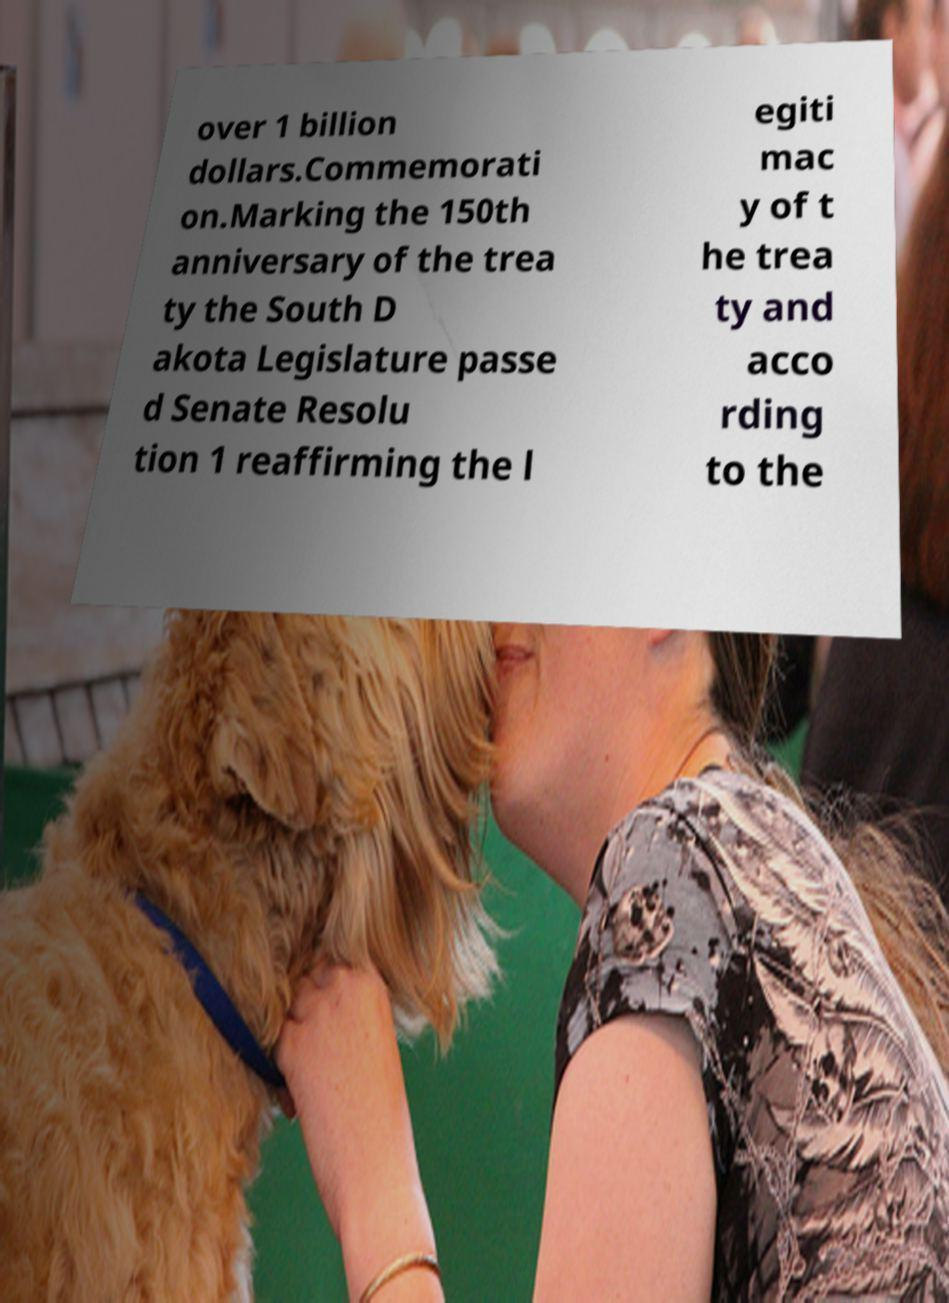I need the written content from this picture converted into text. Can you do that? over 1 billion dollars.Commemorati on.Marking the 150th anniversary of the trea ty the South D akota Legislature passe d Senate Resolu tion 1 reaffirming the l egiti mac y of t he trea ty and acco rding to the 